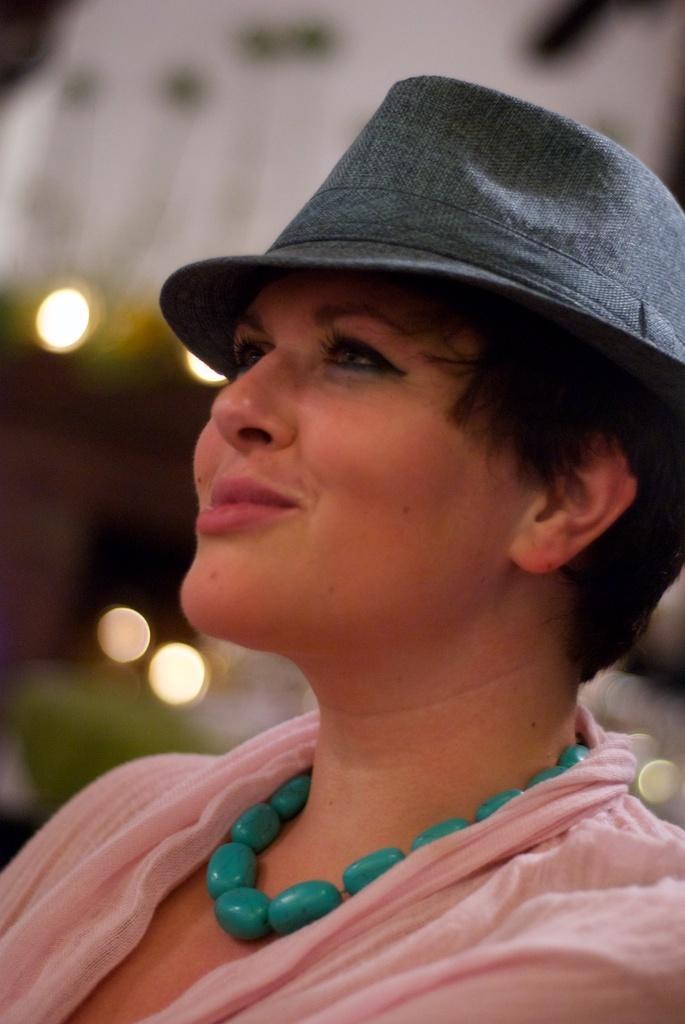Can you describe this image briefly? In this picture we can see a woman wearing pink color dress with grey color cowboy cap sitting and smiling. 